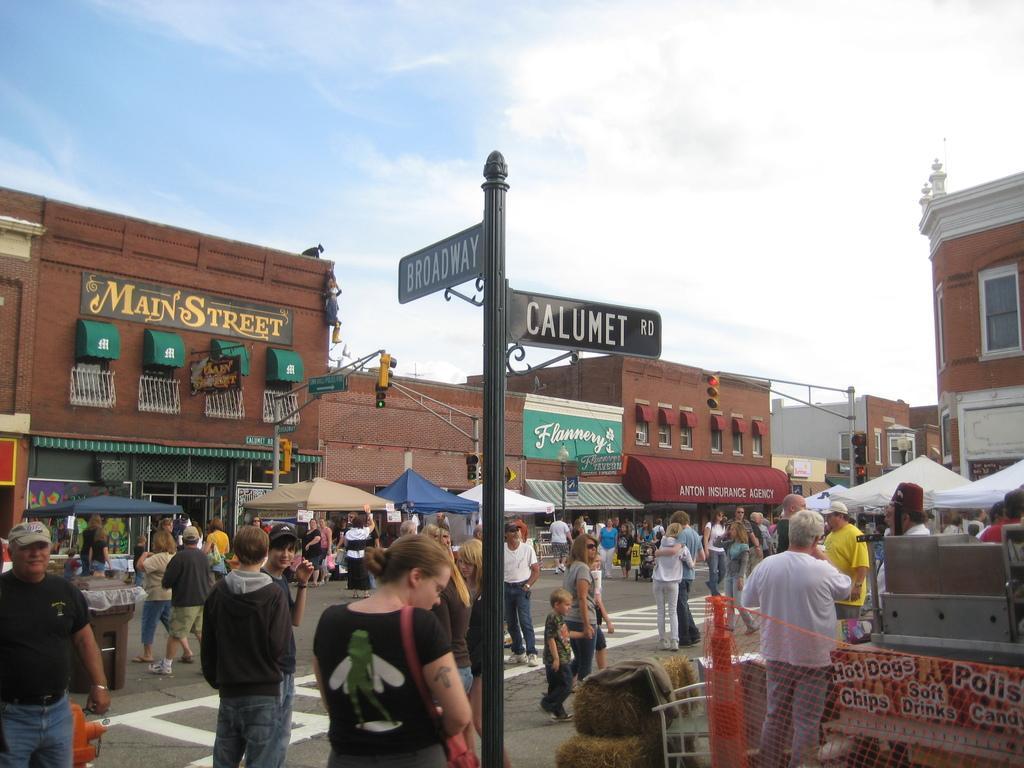How would you summarize this image in a sentence or two? In the foreground I can see a crowd on the road, chairs, metal rods, boards, posters, vehicles, shops, tents, light pole, windows and buildings. In the background I can see the sky. This image is taken may be on the road. 